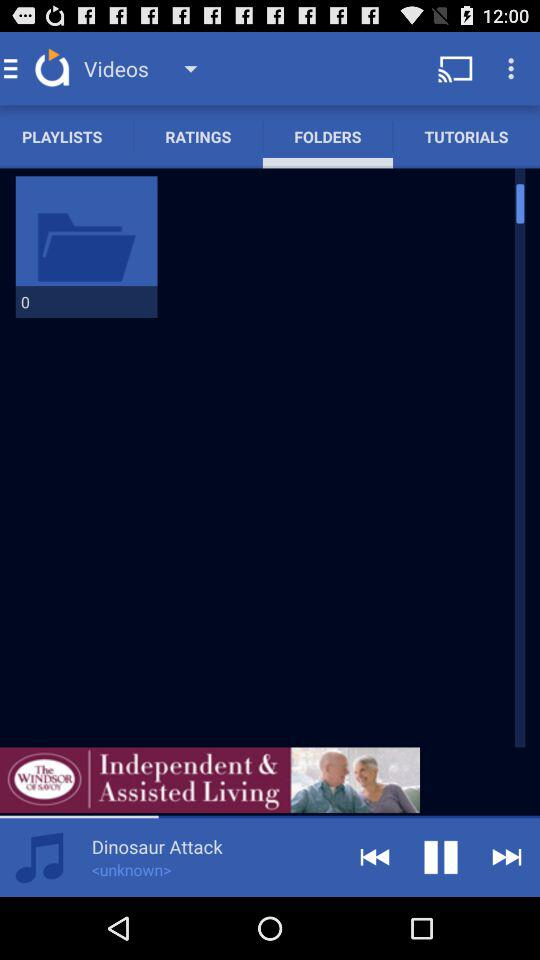Which audio is currently playing? The audio currently playing is "Dinosaur Attack". 